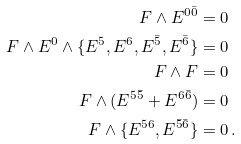<formula> <loc_0><loc_0><loc_500><loc_500>F \wedge { E } ^ { 0 \bar { 0 } } & = 0 \\ F \wedge { E } ^ { 0 } \wedge \{ { E } ^ { 5 } , { E } ^ { 6 } , { E } ^ { \bar { 5 } } , { E } ^ { \bar { 6 } } \} & = 0 \\ F \wedge F & = 0 \\ F \wedge ( { E } ^ { 5 \bar { 5 } } + { E } ^ { 6 \bar { 6 } } ) & = 0 \\ F \wedge \{ { E } ^ { 5 6 } , { E } ^ { { \bar { 5 } } { \bar { 6 } } } \} & = 0 \, .</formula> 